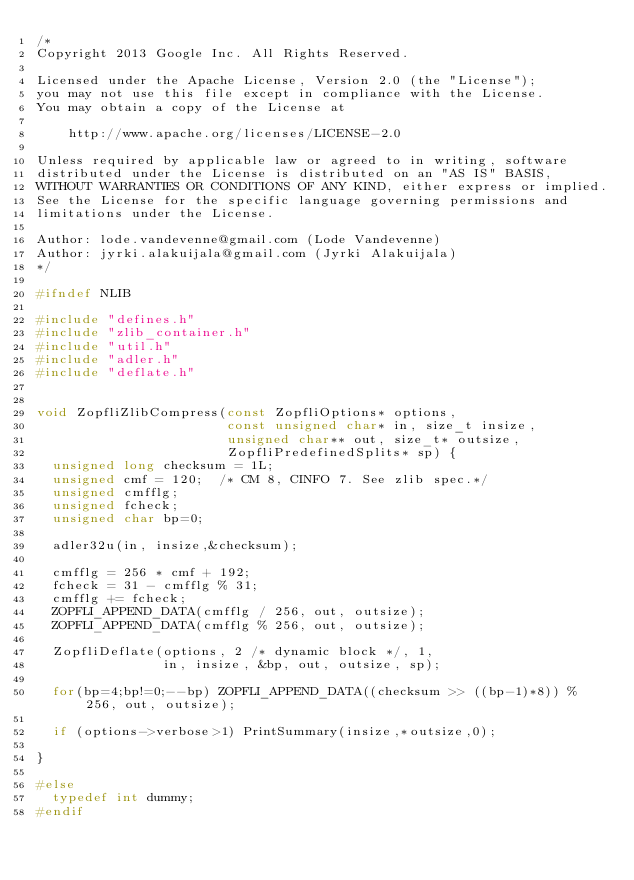Convert code to text. <code><loc_0><loc_0><loc_500><loc_500><_C_>/*
Copyright 2013 Google Inc. All Rights Reserved.

Licensed under the Apache License, Version 2.0 (the "License");
you may not use this file except in compliance with the License.
You may obtain a copy of the License at

    http://www.apache.org/licenses/LICENSE-2.0

Unless required by applicable law or agreed to in writing, software
distributed under the License is distributed on an "AS IS" BASIS,
WITHOUT WARRANTIES OR CONDITIONS OF ANY KIND, either express or implied.
See the License for the specific language governing permissions and
limitations under the License.

Author: lode.vandevenne@gmail.com (Lode Vandevenne)
Author: jyrki.alakuijala@gmail.com (Jyrki Alakuijala)
*/

#ifndef NLIB

#include "defines.h"
#include "zlib_container.h"
#include "util.h"
#include "adler.h"
#include "deflate.h"


void ZopfliZlibCompress(const ZopfliOptions* options,
                        const unsigned char* in, size_t insize,
                        unsigned char** out, size_t* outsize,
                        ZopfliPredefinedSplits* sp) {
  unsigned long checksum = 1L;
  unsigned cmf = 120;  /* CM 8, CINFO 7. See zlib spec.*/
  unsigned cmfflg;
  unsigned fcheck;
  unsigned char bp=0;

  adler32u(in, insize,&checksum);

  cmfflg = 256 * cmf + 192;
  fcheck = 31 - cmfflg % 31;
  cmfflg += fcheck;
  ZOPFLI_APPEND_DATA(cmfflg / 256, out, outsize);
  ZOPFLI_APPEND_DATA(cmfflg % 256, out, outsize);

  ZopfliDeflate(options, 2 /* dynamic block */, 1,
                in, insize, &bp, out, outsize, sp);

  for(bp=4;bp!=0;--bp) ZOPFLI_APPEND_DATA((checksum >> ((bp-1)*8)) % 256, out, outsize);

  if (options->verbose>1) PrintSummary(insize,*outsize,0);

}

#else
  typedef int dummy;
#endif
</code> 